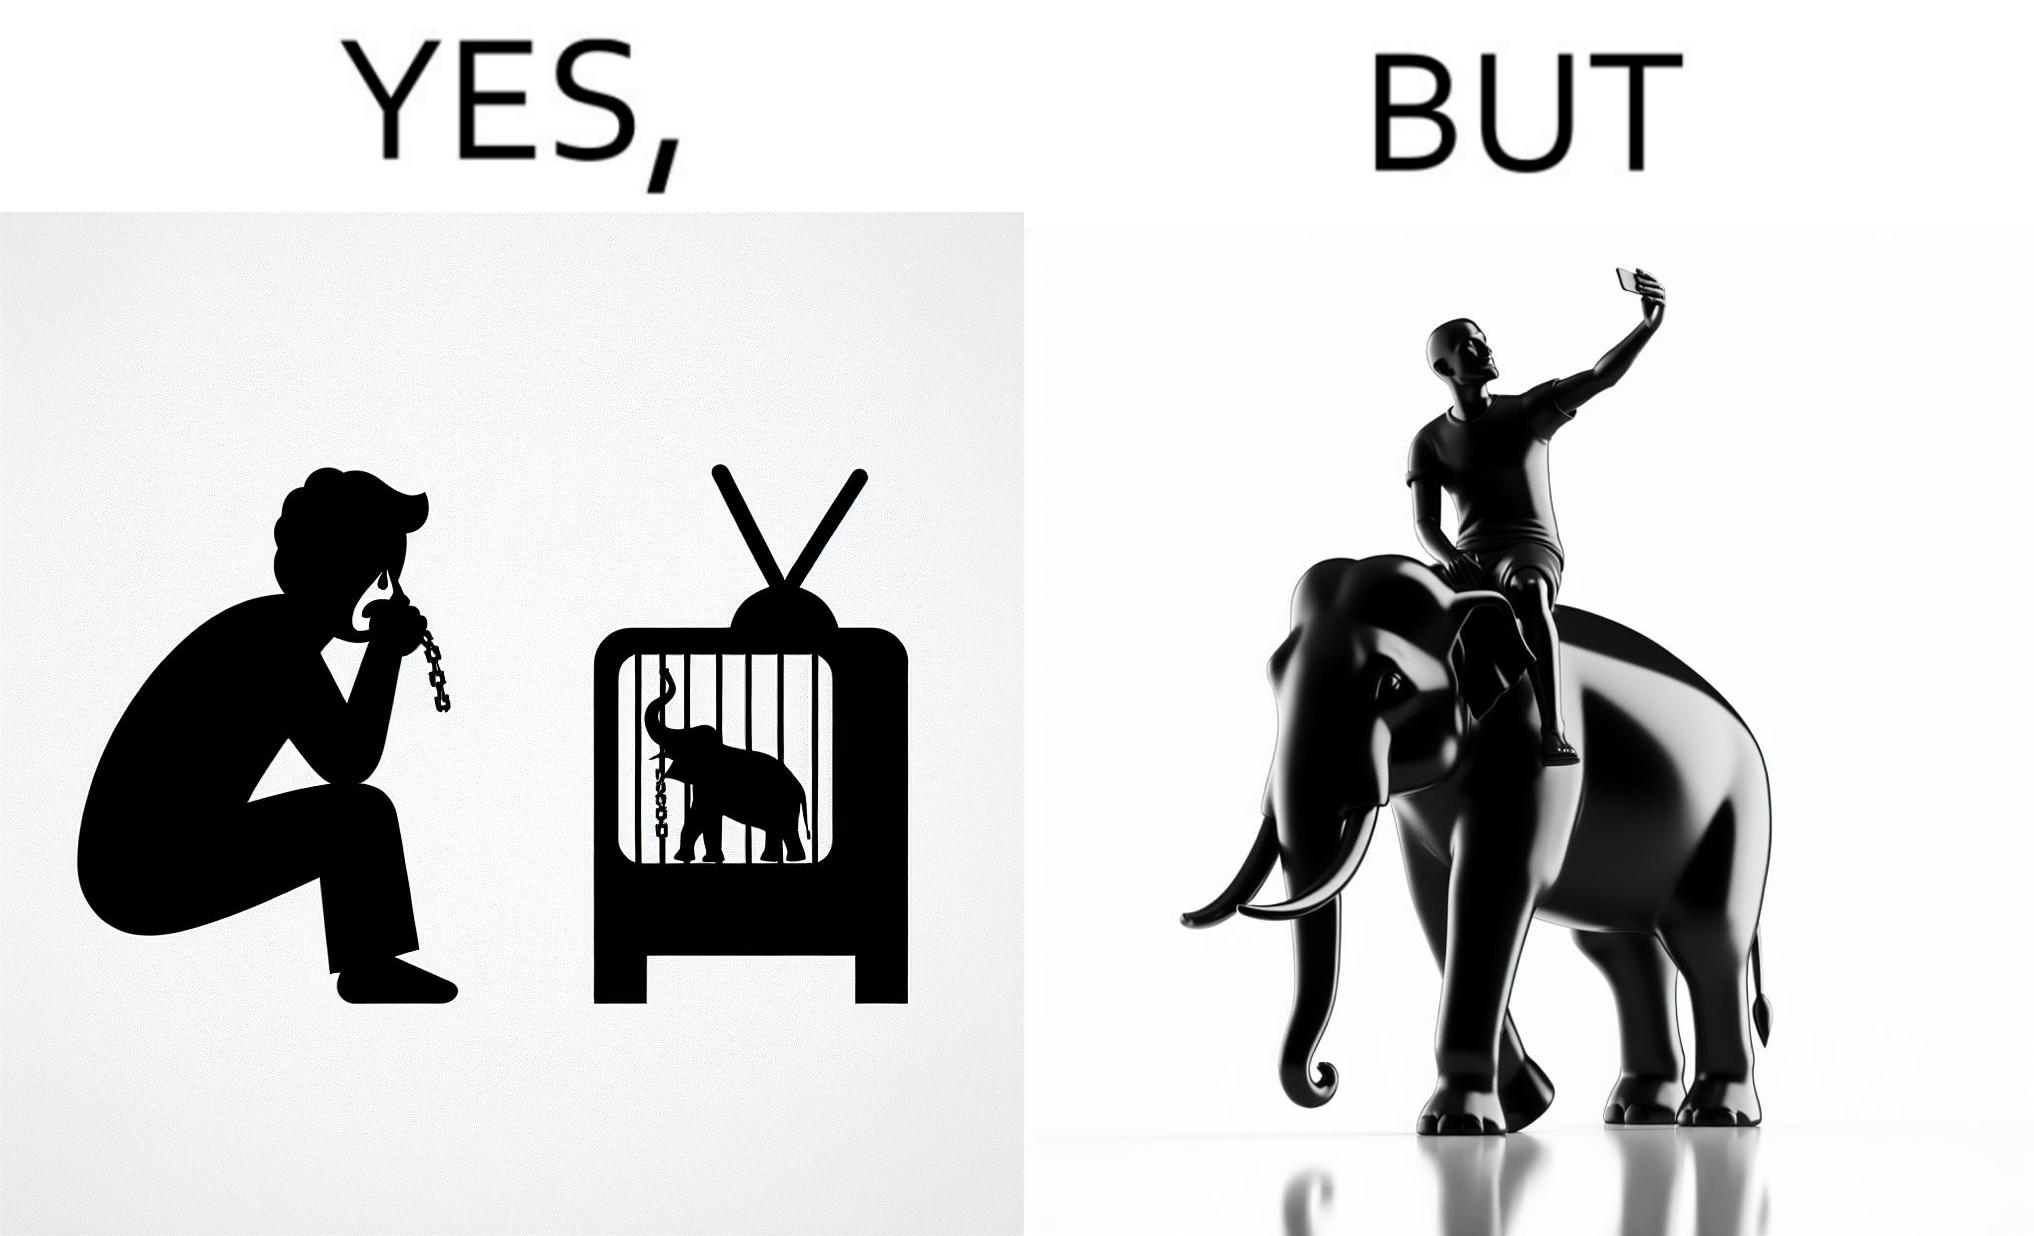What does this image depict? The image is ironic, because the people who get sentimental over imprisoned animal while watching TV shows often feel okay when using animals for labor 